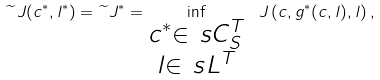<formula> <loc_0><loc_0><loc_500><loc_500>\widetilde { \ } J ( c ^ { * } , l ^ { * } ) = \widetilde { \ } J ^ { * } = \inf _ { \substack { c ^ { * } \in \ s C _ { S } ^ { T } \\ l \in \ s L ^ { T } } } \ J \left ( c , g ^ { * } ( c , l ) , l \right ) ,</formula> 